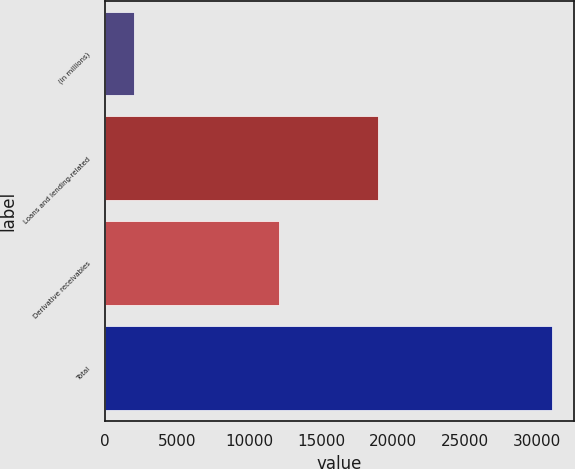<chart> <loc_0><loc_0><loc_500><loc_500><bar_chart><fcel>(in millions)<fcel>Loans and lending-related<fcel>Derivative receivables<fcel>Total<nl><fcel>2005<fcel>18926<fcel>12088<fcel>31014<nl></chart> 